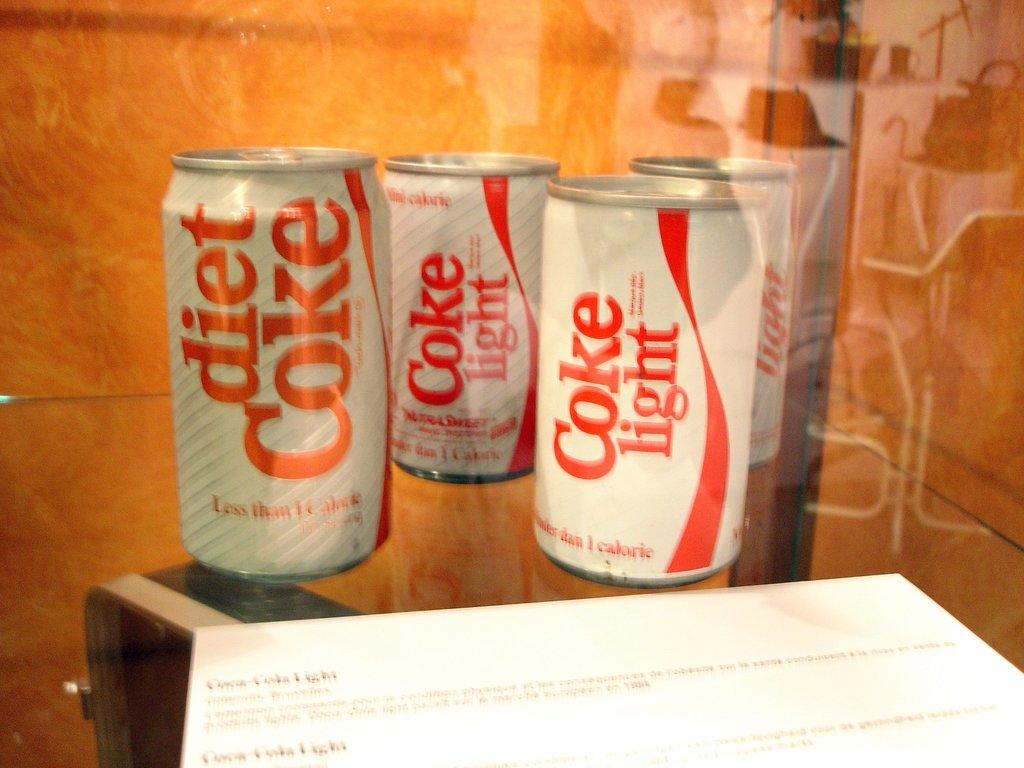<image>
Relay a brief, clear account of the picture shown. Three cans of white and red diet coke soda behind glass. 